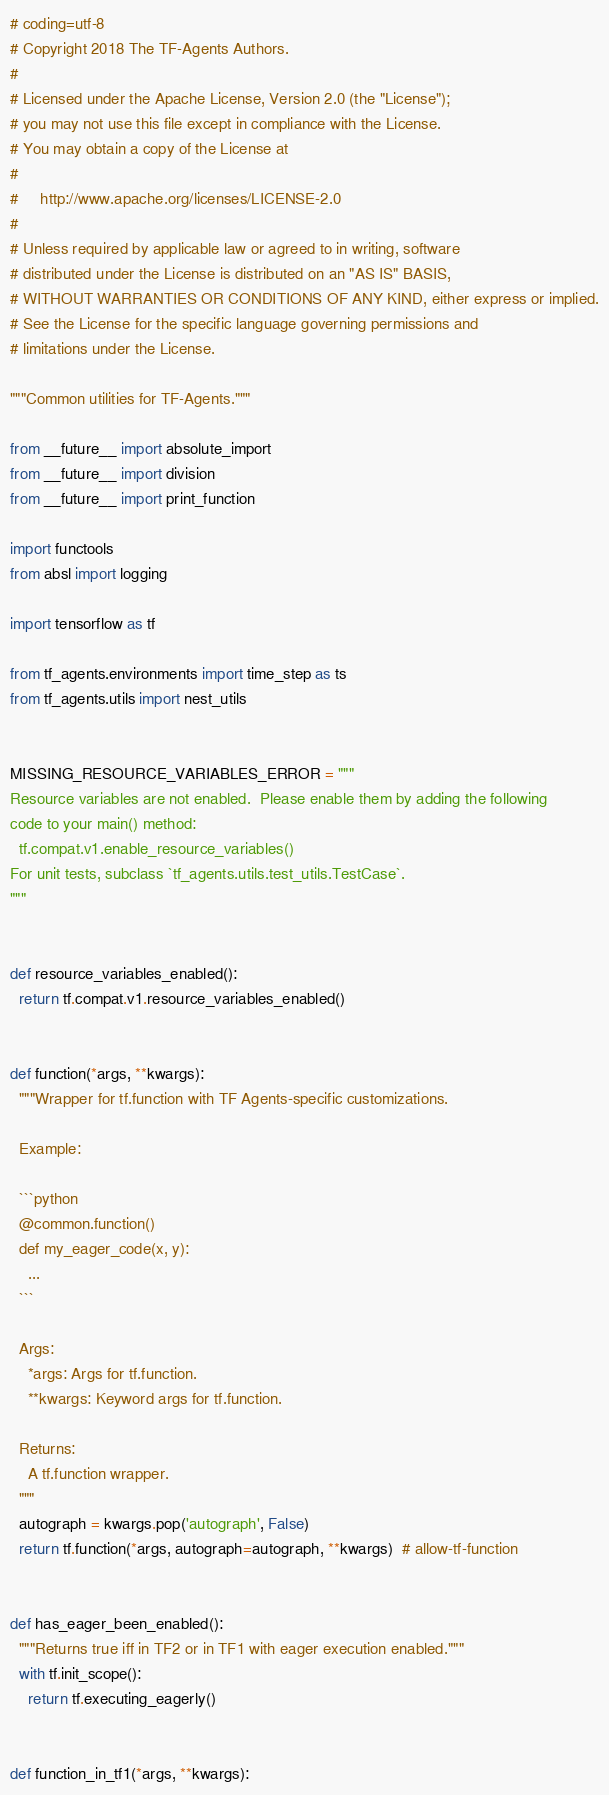Convert code to text. <code><loc_0><loc_0><loc_500><loc_500><_Python_># coding=utf-8
# Copyright 2018 The TF-Agents Authors.
#
# Licensed under the Apache License, Version 2.0 (the "License");
# you may not use this file except in compliance with the License.
# You may obtain a copy of the License at
#
#     http://www.apache.org/licenses/LICENSE-2.0
#
# Unless required by applicable law or agreed to in writing, software
# distributed under the License is distributed on an "AS IS" BASIS,
# WITHOUT WARRANTIES OR CONDITIONS OF ANY KIND, either express or implied.
# See the License for the specific language governing permissions and
# limitations under the License.

"""Common utilities for TF-Agents."""

from __future__ import absolute_import
from __future__ import division
from __future__ import print_function

import functools
from absl import logging

import tensorflow as tf

from tf_agents.environments import time_step as ts
from tf_agents.utils import nest_utils


MISSING_RESOURCE_VARIABLES_ERROR = """
Resource variables are not enabled.  Please enable them by adding the following
code to your main() method:
  tf.compat.v1.enable_resource_variables()
For unit tests, subclass `tf_agents.utils.test_utils.TestCase`.
"""


def resource_variables_enabled():
  return tf.compat.v1.resource_variables_enabled()


def function(*args, **kwargs):
  """Wrapper for tf.function with TF Agents-specific customizations.

  Example:

  ```python
  @common.function()
  def my_eager_code(x, y):
    ...
  ```

  Args:
    *args: Args for tf.function.
    **kwargs: Keyword args for tf.function.

  Returns:
    A tf.function wrapper.
  """
  autograph = kwargs.pop('autograph', False)
  return tf.function(*args, autograph=autograph, **kwargs)  # allow-tf-function


def has_eager_been_enabled():
  """Returns true iff in TF2 or in TF1 with eager execution enabled."""
  with tf.init_scope():
    return tf.executing_eagerly()


def function_in_tf1(*args, **kwargs):</code> 